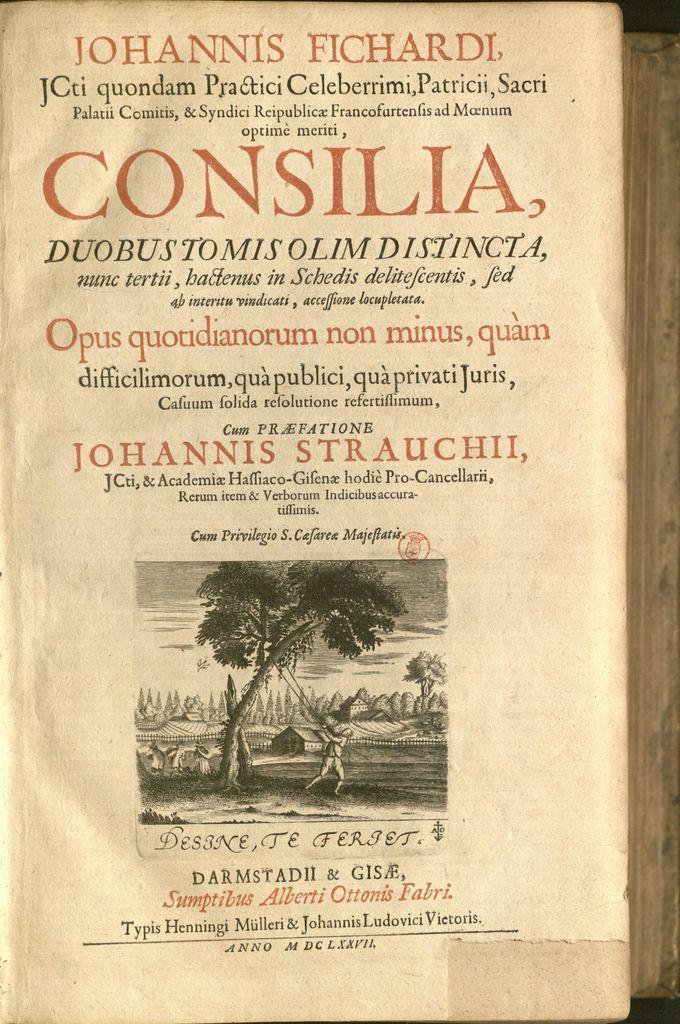Could you give a brief overview of what you see in this image? In this image we can see the front view of a book with the text and also the picture. 